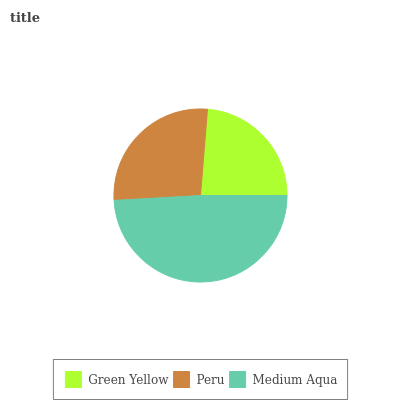Is Green Yellow the minimum?
Answer yes or no. Yes. Is Medium Aqua the maximum?
Answer yes or no. Yes. Is Peru the minimum?
Answer yes or no. No. Is Peru the maximum?
Answer yes or no. No. Is Peru greater than Green Yellow?
Answer yes or no. Yes. Is Green Yellow less than Peru?
Answer yes or no. Yes. Is Green Yellow greater than Peru?
Answer yes or no. No. Is Peru less than Green Yellow?
Answer yes or no. No. Is Peru the high median?
Answer yes or no. Yes. Is Peru the low median?
Answer yes or no. Yes. Is Green Yellow the high median?
Answer yes or no. No. Is Green Yellow the low median?
Answer yes or no. No. 